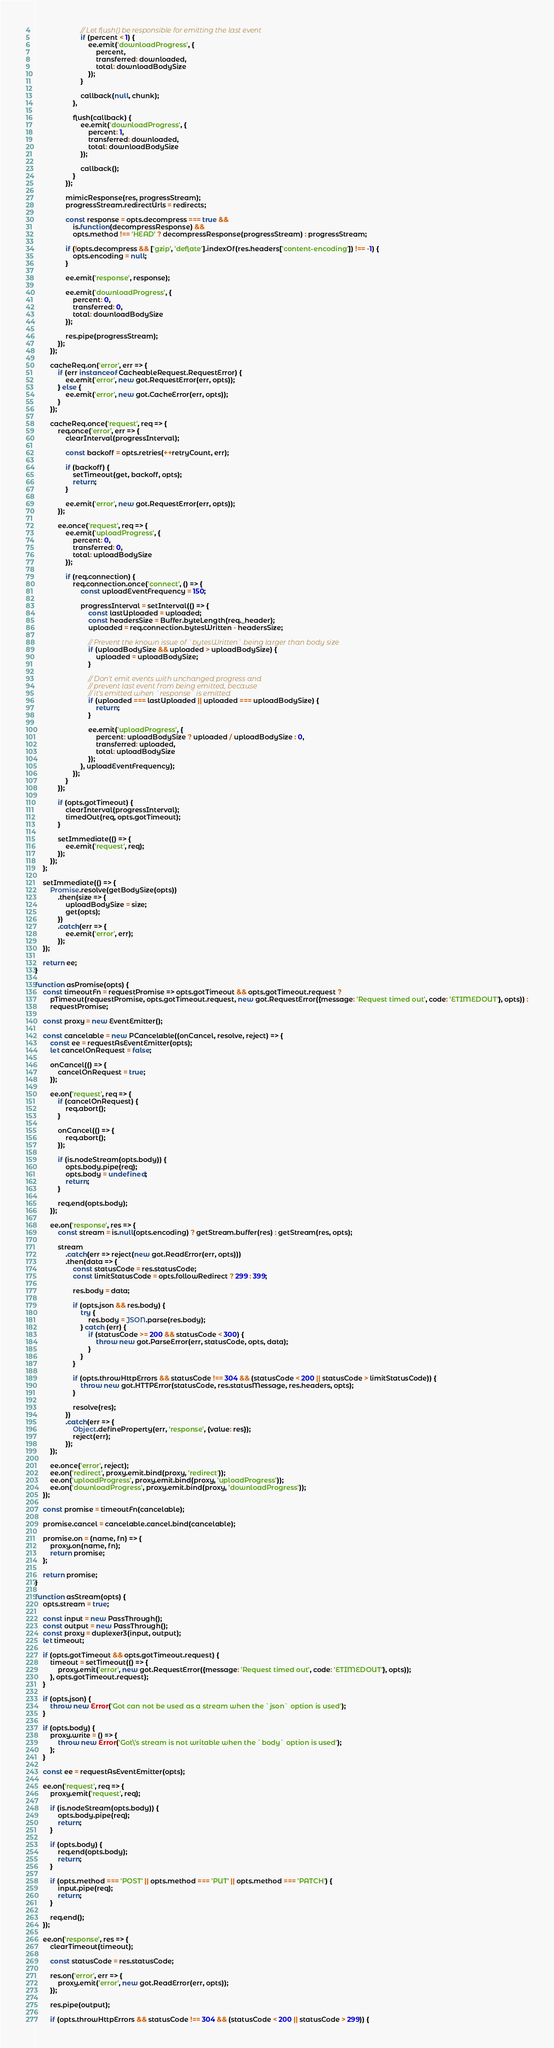Convert code to text. <code><loc_0><loc_0><loc_500><loc_500><_JavaScript_>						// Let flush() be responsible for emitting the last event
						if (percent < 1) {
							ee.emit('downloadProgress', {
								percent,
								transferred: downloaded,
								total: downloadBodySize
							});
						}

						callback(null, chunk);
					},

					flush(callback) {
						ee.emit('downloadProgress', {
							percent: 1,
							transferred: downloaded,
							total: downloadBodySize
						});

						callback();
					}
				});

				mimicResponse(res, progressStream);
				progressStream.redirectUrls = redirects;

				const response = opts.decompress === true &&
					is.function(decompressResponse) &&
					opts.method !== 'HEAD' ? decompressResponse(progressStream) : progressStream;

				if (!opts.decompress && ['gzip', 'deflate'].indexOf(res.headers['content-encoding']) !== -1) {
					opts.encoding = null;
				}

				ee.emit('response', response);

				ee.emit('downloadProgress', {
					percent: 0,
					transferred: 0,
					total: downloadBodySize
				});

				res.pipe(progressStream);
			});
		});

		cacheReq.on('error', err => {
			if (err instanceof CacheableRequest.RequestError) {
				ee.emit('error', new got.RequestError(err, opts));
			} else {
				ee.emit('error', new got.CacheError(err, opts));
			}
		});

		cacheReq.once('request', req => {
			req.once('error', err => {
				clearInterval(progressInterval);

				const backoff = opts.retries(++retryCount, err);

				if (backoff) {
					setTimeout(get, backoff, opts);
					return;
				}

				ee.emit('error', new got.RequestError(err, opts));
			});

			ee.once('request', req => {
				ee.emit('uploadProgress', {
					percent: 0,
					transferred: 0,
					total: uploadBodySize
				});

				if (req.connection) {
					req.connection.once('connect', () => {
						const uploadEventFrequency = 150;

						progressInterval = setInterval(() => {
							const lastUploaded = uploaded;
							const headersSize = Buffer.byteLength(req._header);
							uploaded = req.connection.bytesWritten - headersSize;

							// Prevent the known issue of `bytesWritten` being larger than body size
							if (uploadBodySize && uploaded > uploadBodySize) {
								uploaded = uploadBodySize;
							}

							// Don't emit events with unchanged progress and
							// prevent last event from being emitted, because
							// it's emitted when `response` is emitted
							if (uploaded === lastUploaded || uploaded === uploadBodySize) {
								return;
							}

							ee.emit('uploadProgress', {
								percent: uploadBodySize ? uploaded / uploadBodySize : 0,
								transferred: uploaded,
								total: uploadBodySize
							});
						}, uploadEventFrequency);
					});
				}
			});

			if (opts.gotTimeout) {
				clearInterval(progressInterval);
				timedOut(req, opts.gotTimeout);
			}

			setImmediate(() => {
				ee.emit('request', req);
			});
		});
	};

	setImmediate(() => {
		Promise.resolve(getBodySize(opts))
			.then(size => {
				uploadBodySize = size;
				get(opts);
			})
			.catch(err => {
				ee.emit('error', err);
			});
	});

	return ee;
}

function asPromise(opts) {
	const timeoutFn = requestPromise => opts.gotTimeout && opts.gotTimeout.request ?
		pTimeout(requestPromise, opts.gotTimeout.request, new got.RequestError({message: 'Request timed out', code: 'ETIMEDOUT'}, opts)) :
		requestPromise;

	const proxy = new EventEmitter();

	const cancelable = new PCancelable((onCancel, resolve, reject) => {
		const ee = requestAsEventEmitter(opts);
		let cancelOnRequest = false;

		onCancel(() => {
			cancelOnRequest = true;
		});

		ee.on('request', req => {
			if (cancelOnRequest) {
				req.abort();
			}

			onCancel(() => {
				req.abort();
			});

			if (is.nodeStream(opts.body)) {
				opts.body.pipe(req);
				opts.body = undefined;
				return;
			}

			req.end(opts.body);
		});

		ee.on('response', res => {
			const stream = is.null(opts.encoding) ? getStream.buffer(res) : getStream(res, opts);

			stream
				.catch(err => reject(new got.ReadError(err, opts)))
				.then(data => {
					const statusCode = res.statusCode;
					const limitStatusCode = opts.followRedirect ? 299 : 399;

					res.body = data;

					if (opts.json && res.body) {
						try {
							res.body = JSON.parse(res.body);
						} catch (err) {
							if (statusCode >= 200 && statusCode < 300) {
								throw new got.ParseError(err, statusCode, opts, data);
							}
						}
					}

					if (opts.throwHttpErrors && statusCode !== 304 && (statusCode < 200 || statusCode > limitStatusCode)) {
						throw new got.HTTPError(statusCode, res.statusMessage, res.headers, opts);
					}

					resolve(res);
				})
				.catch(err => {
					Object.defineProperty(err, 'response', {value: res});
					reject(err);
				});
		});

		ee.once('error', reject);
		ee.on('redirect', proxy.emit.bind(proxy, 'redirect'));
		ee.on('uploadProgress', proxy.emit.bind(proxy, 'uploadProgress'));
		ee.on('downloadProgress', proxy.emit.bind(proxy, 'downloadProgress'));
	});

	const promise = timeoutFn(cancelable);

	promise.cancel = cancelable.cancel.bind(cancelable);

	promise.on = (name, fn) => {
		proxy.on(name, fn);
		return promise;
	};

	return promise;
}

function asStream(opts) {
	opts.stream = true;

	const input = new PassThrough();
	const output = new PassThrough();
	const proxy = duplexer3(input, output);
	let timeout;

	if (opts.gotTimeout && opts.gotTimeout.request) {
		timeout = setTimeout(() => {
			proxy.emit('error', new got.RequestError({message: 'Request timed out', code: 'ETIMEDOUT'}, opts));
		}, opts.gotTimeout.request);
	}

	if (opts.json) {
		throw new Error('Got can not be used as a stream when the `json` option is used');
	}

	if (opts.body) {
		proxy.write = () => {
			throw new Error('Got\'s stream is not writable when the `body` option is used');
		};
	}

	const ee = requestAsEventEmitter(opts);

	ee.on('request', req => {
		proxy.emit('request', req);

		if (is.nodeStream(opts.body)) {
			opts.body.pipe(req);
			return;
		}

		if (opts.body) {
			req.end(opts.body);
			return;
		}

		if (opts.method === 'POST' || opts.method === 'PUT' || opts.method === 'PATCH') {
			input.pipe(req);
			return;
		}

		req.end();
	});

	ee.on('response', res => {
		clearTimeout(timeout);

		const statusCode = res.statusCode;

		res.on('error', err => {
			proxy.emit('error', new got.ReadError(err, opts));
		});

		res.pipe(output);

		if (opts.throwHttpErrors && statusCode !== 304 && (statusCode < 200 || statusCode > 299)) {</code> 